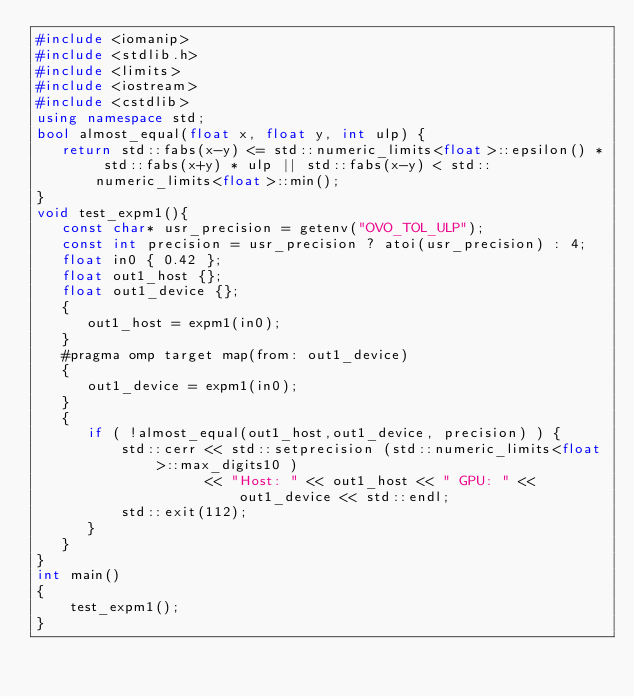<code> <loc_0><loc_0><loc_500><loc_500><_C++_>#include <iomanip>
#include <stdlib.h>
#include <limits>
#include <iostream>
#include <cstdlib>
using namespace std;
bool almost_equal(float x, float y, int ulp) {
   return std::fabs(x-y) <= std::numeric_limits<float>::epsilon() * std::fabs(x+y) * ulp || std::fabs(x-y) < std::numeric_limits<float>::min();
}
void test_expm1(){
   const char* usr_precision = getenv("OVO_TOL_ULP");
   const int precision = usr_precision ? atoi(usr_precision) : 4;
   float in0 { 0.42 };
   float out1_host {};
   float out1_device {};
   {
      out1_host = expm1(in0);
   }
   #pragma omp target map(from: out1_device)
   {
      out1_device = expm1(in0);
   }
   {
      if ( !almost_equal(out1_host,out1_device, precision) ) {
          std::cerr << std::setprecision (std::numeric_limits<float>::max_digits10 )
                    << "Host: " << out1_host << " GPU: " << out1_device << std::endl;
          std::exit(112);
      }
   }
}
int main()
{
    test_expm1();
}
</code> 